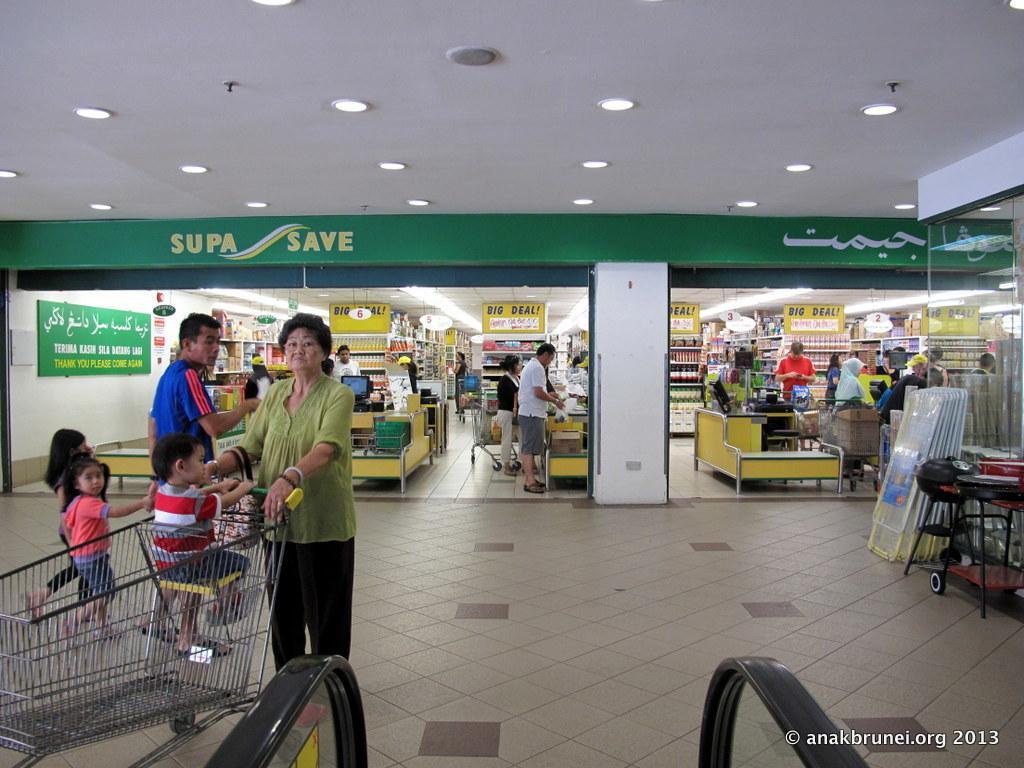Please provide a concise description of this image. As we can see in the image there are few people here and there, banner, wall, lights, cart and there are few furnitures. 